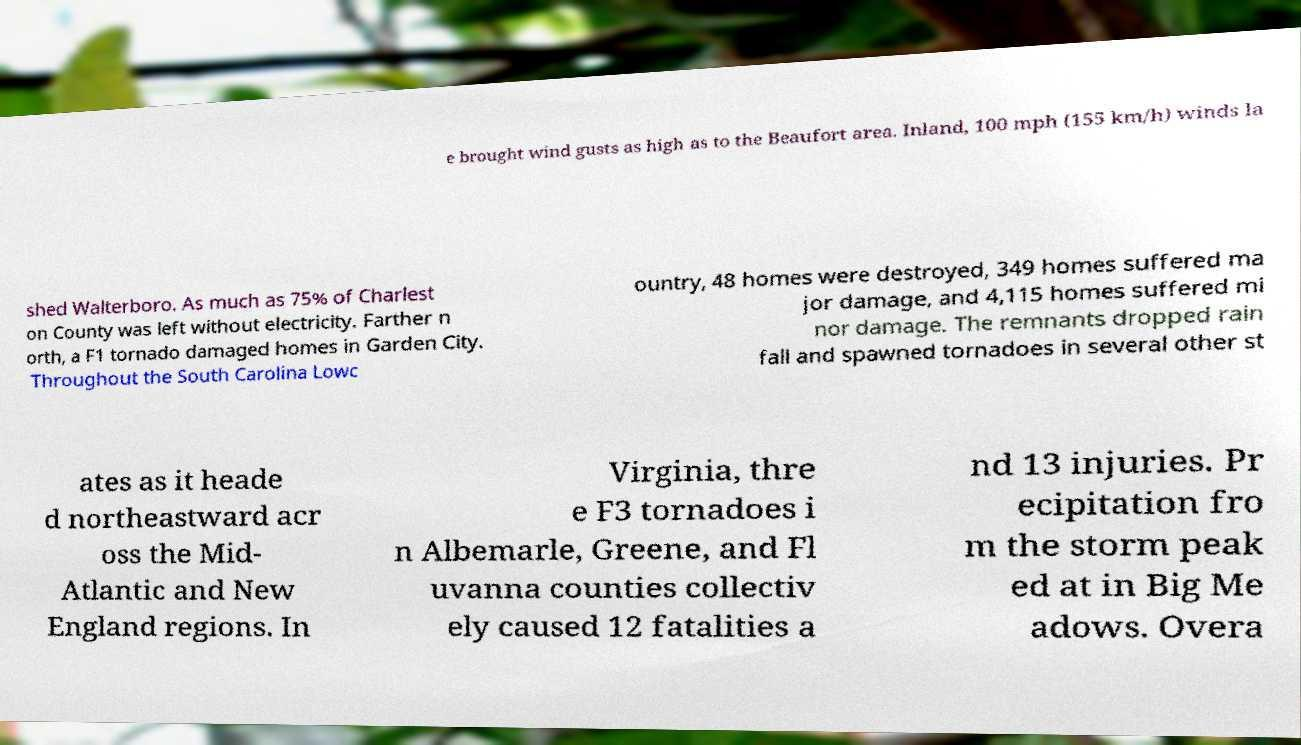Could you assist in decoding the text presented in this image and type it out clearly? e brought wind gusts as high as to the Beaufort area. Inland, 100 mph (155 km/h) winds la shed Walterboro. As much as 75% of Charlest on County was left without electricity. Farther n orth, a F1 tornado damaged homes in Garden City. Throughout the South Carolina Lowc ountry, 48 homes were destroyed, 349 homes suffered ma jor damage, and 4,115 homes suffered mi nor damage. The remnants dropped rain fall and spawned tornadoes in several other st ates as it heade d northeastward acr oss the Mid- Atlantic and New England regions. In Virginia, thre e F3 tornadoes i n Albemarle, Greene, and Fl uvanna counties collectiv ely caused 12 fatalities a nd 13 injuries. Pr ecipitation fro m the storm peak ed at in Big Me adows. Overa 